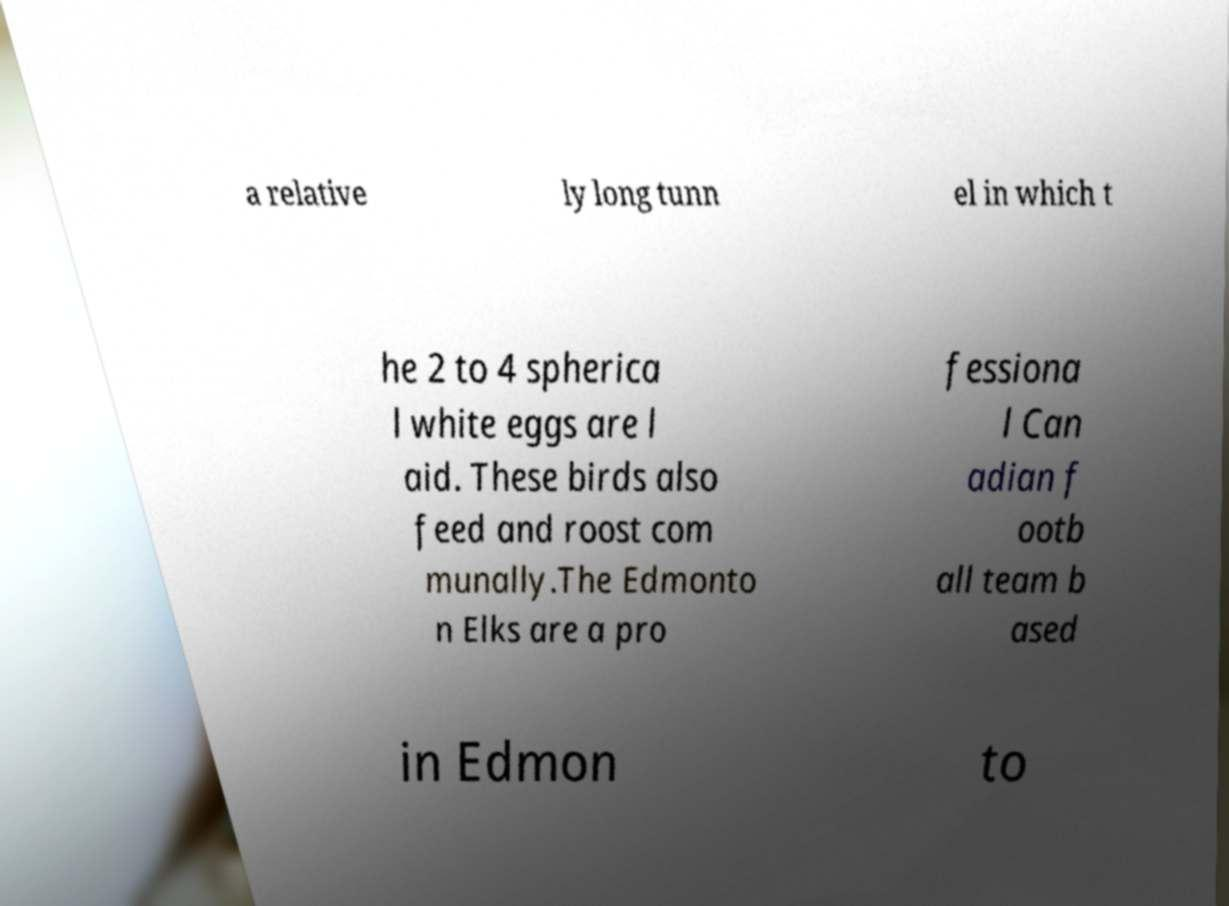Can you read and provide the text displayed in the image?This photo seems to have some interesting text. Can you extract and type it out for me? a relative ly long tunn el in which t he 2 to 4 spherica l white eggs are l aid. These birds also feed and roost com munally.The Edmonto n Elks are a pro fessiona l Can adian f ootb all team b ased in Edmon to 